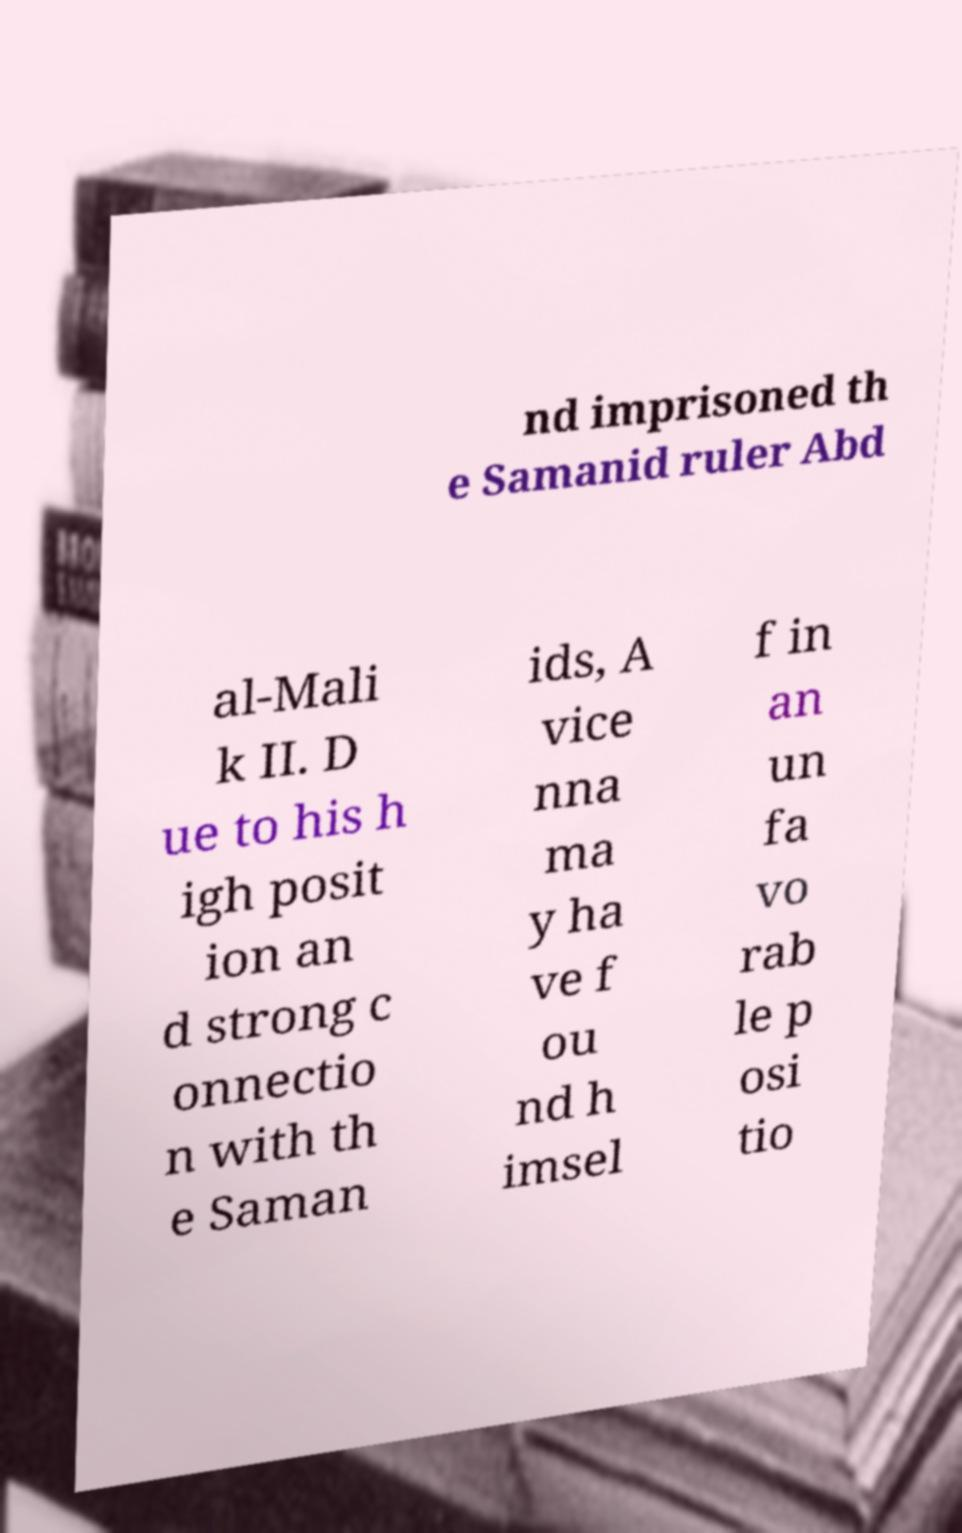Please identify and transcribe the text found in this image. nd imprisoned th e Samanid ruler Abd al-Mali k II. D ue to his h igh posit ion an d strong c onnectio n with th e Saman ids, A vice nna ma y ha ve f ou nd h imsel f in an un fa vo rab le p osi tio 